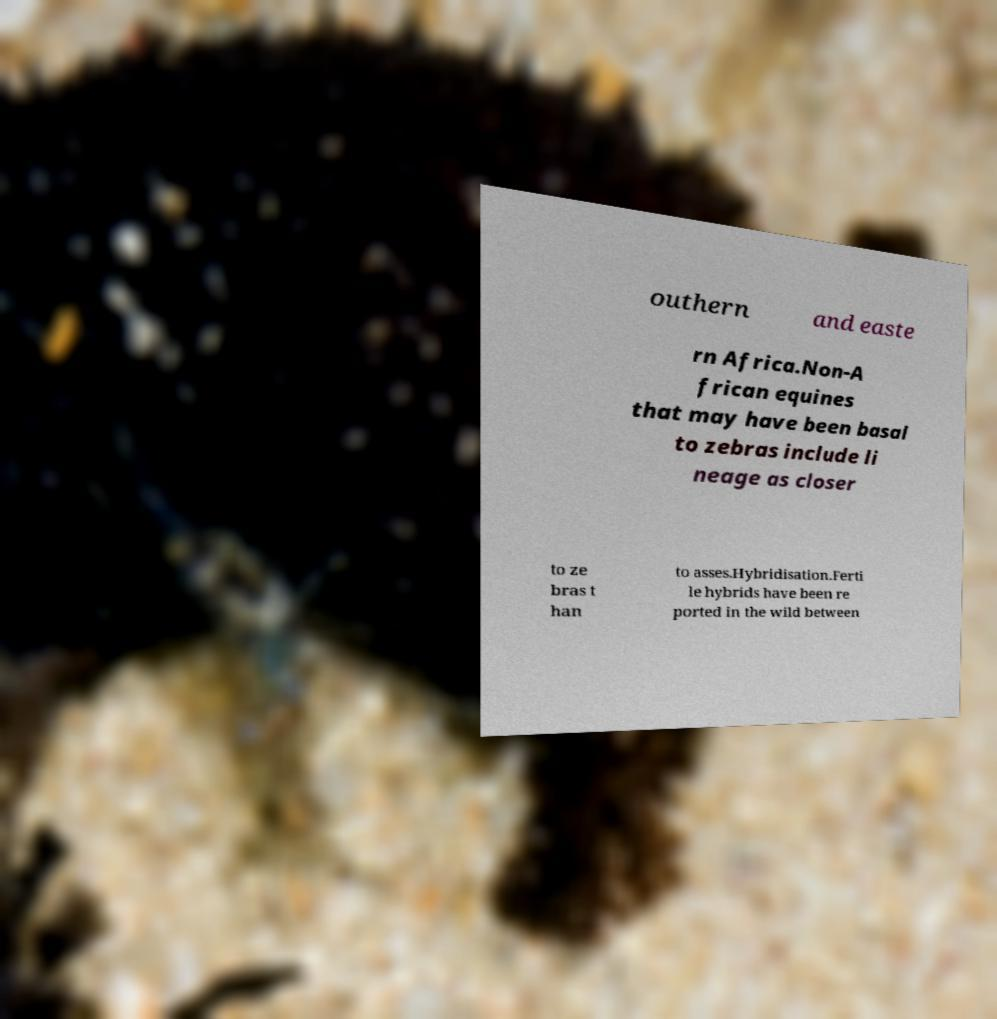There's text embedded in this image that I need extracted. Can you transcribe it verbatim? outhern and easte rn Africa.Non-A frican equines that may have been basal to zebras include li neage as closer to ze bras t han to asses.Hybridisation.Ferti le hybrids have been re ported in the wild between 